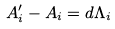<formula> <loc_0><loc_0><loc_500><loc_500>A _ { i } ^ { \prime } - A _ { i } = d \Lambda _ { i }</formula> 